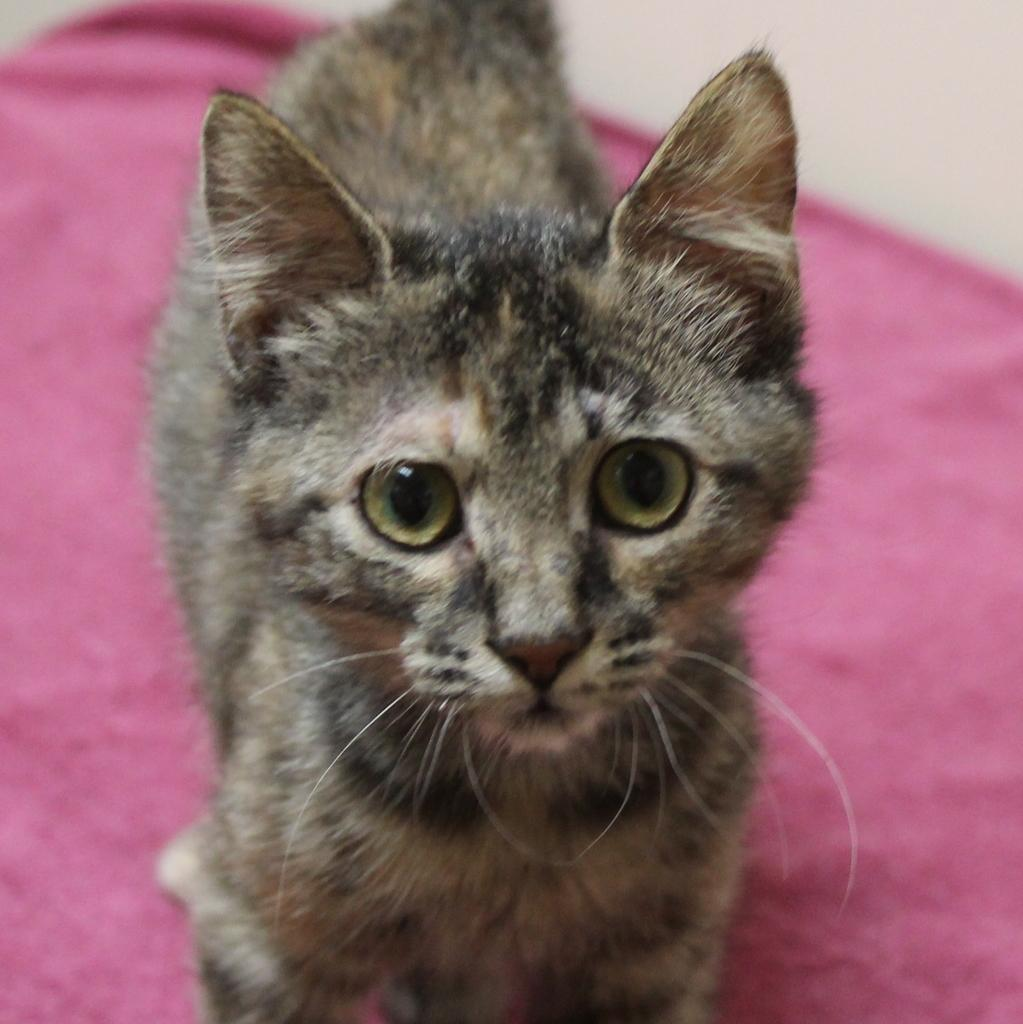What is the main subject in the foreground of the image? There is a cat in the foreground of the image. What is the cat standing on? The cat is standing on a pink object. What can be seen in the background of the image? There is a wall in the background of the image. What type of crime is being committed by the creature in the image? There is no creature or crime present in the image; it features a cat standing on a pink object with a wall in the background. 